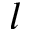<formula> <loc_0><loc_0><loc_500><loc_500>l</formula> 